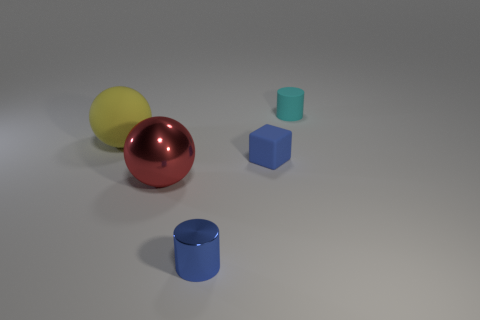Add 5 cyan matte cylinders. How many objects exist? 10 Subtract all cubes. How many objects are left? 4 Subtract all blocks. Subtract all tiny rubber objects. How many objects are left? 2 Add 1 large red metal objects. How many large red metal objects are left? 2 Add 4 large yellow spheres. How many large yellow spheres exist? 5 Subtract 0 purple blocks. How many objects are left? 5 